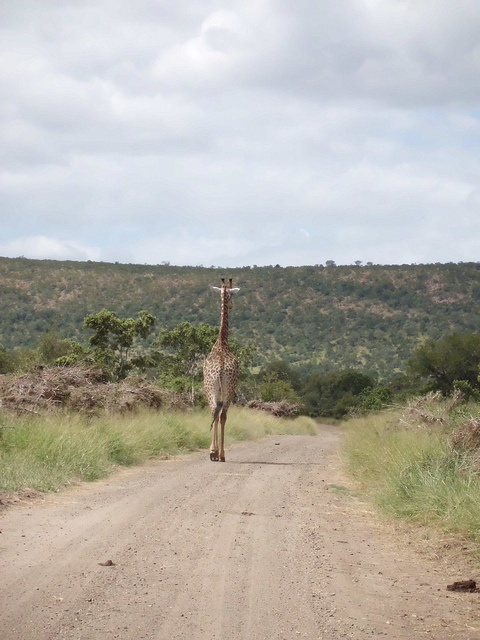Describe the objects in this image and their specific colors. I can see a giraffe in lightgray, gray, tan, and maroon tones in this image. 